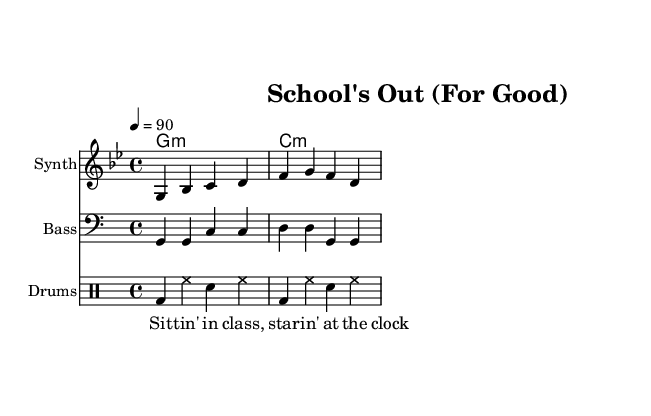What is the key signature of this music? The key signature indicates that there are two flats, specifically B flat and E flat, which defines the G minor scale.
Answer: G minor What is the time signature of this piece? The time signature shows that it is composed in a 4/4 measure, meaning there are four beats in each measure and the quarter note gets one beat.
Answer: 4/4 What is the tempo marking for this piece? The tempo indicates that the piece should be played at a pace of 90 beats per minute, meaning it has a relatively moderate tempo.
Answer: 90 Identify the first lyric of the verse. The lyrics show that the first line begins with the words "Sit tin' in class," indicating the theme of confinement in school.
Answer: Sit tin' in class How many measures are presented in the melody? Counting the distinct groupings of notes in the melody line reveals that there are four measures represented, confirming the structure of the piece.
Answer: 4 Which instrument plays the bass line? The score indicates that the "Bass" staff is clearly labeled and contains the bass line, denoting the instrument responsible for this musical part.
Answer: Bass What genre of fusion does this piece represent? The elements of electronic sounds combined with reggae rhythms and rebellious themes in the lyrics indicate that the music is an electronic-reggae fusion.
Answer: Electronic-reggae fusion 